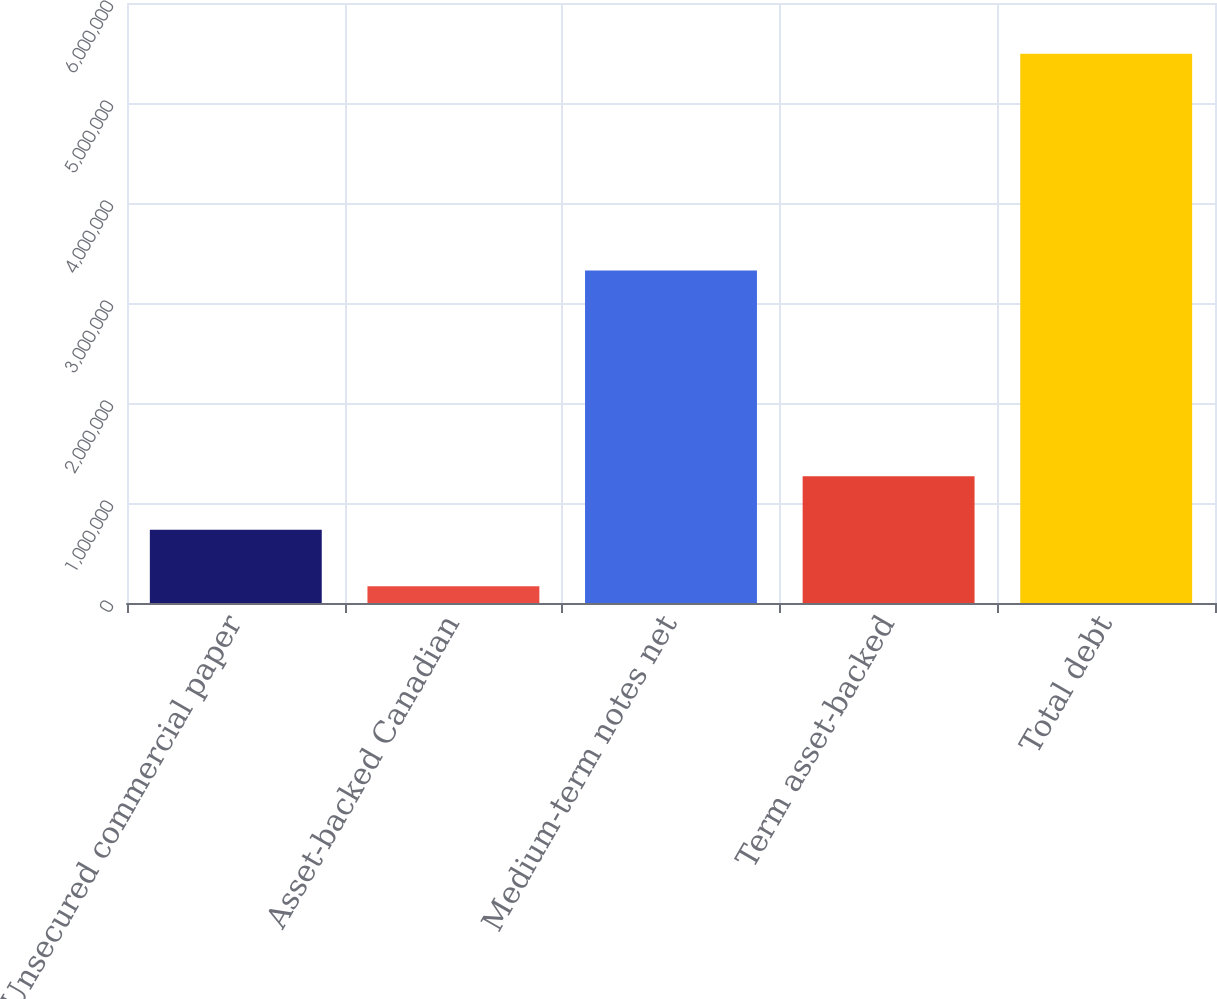Convert chart. <chart><loc_0><loc_0><loc_500><loc_500><bar_chart><fcel>Unsecured commercial paper<fcel>Asset-backed Canadian<fcel>Medium-term notes net<fcel>Term asset-backed<fcel>Total debt<nl><fcel>731786<fcel>166912<fcel>3.32528e+06<fcel>1.26842e+06<fcel>5.4924e+06<nl></chart> 